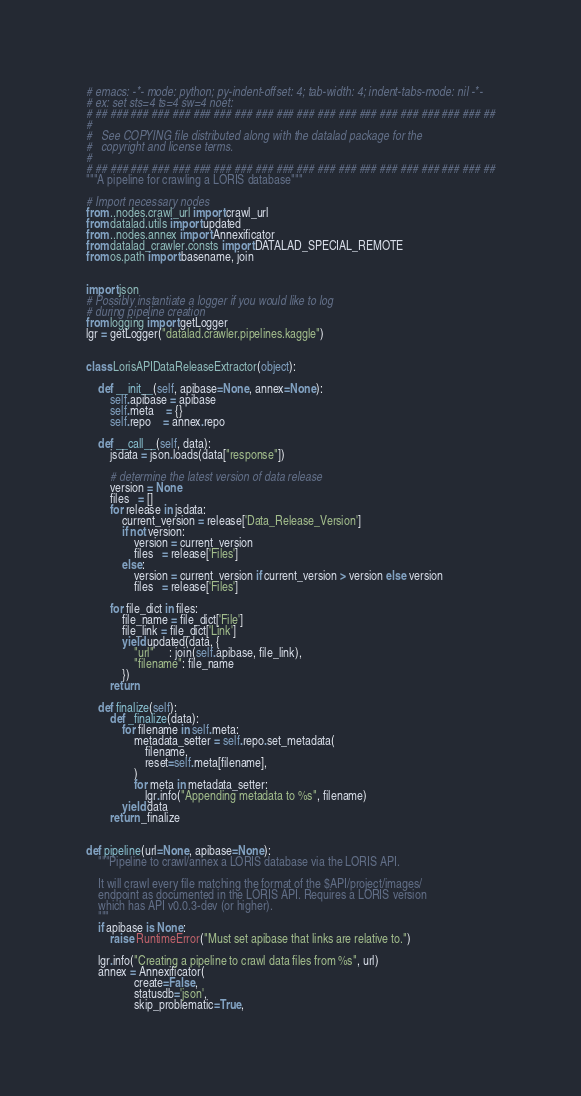<code> <loc_0><loc_0><loc_500><loc_500><_Python_># emacs: -*- mode: python; py-indent-offset: 4; tab-width: 4; indent-tabs-mode: nil -*-
# ex: set sts=4 ts=4 sw=4 noet:
# ## ### ### ### ### ### ### ### ### ### ### ### ### ### ### ### ### ### ### ##
#
#   See COPYING file distributed along with the datalad package for the
#   copyright and license terms.
#
# ## ### ### ### ### ### ### ### ### ### ### ### ### ### ### ### ### ### ### ##
"""A pipeline for crawling a LORIS database"""

# Import necessary nodes
from ..nodes.crawl_url import crawl_url
from datalad.utils import updated
from ..nodes.annex import Annexificator
from datalad_crawler.consts import DATALAD_SPECIAL_REMOTE
from os.path import basename, join


import json
# Possibly instantiate a logger if you would like to log
# during pipeline creation
from logging import getLogger
lgr = getLogger("datalad.crawler.pipelines.kaggle")


class LorisAPIDataReleaseExtractor(object):

    def __init__(self, apibase=None, annex=None):
        self.apibase = apibase
        self.meta    = {}
        self.repo    = annex.repo

    def __call__(self, data):
        jsdata = json.loads(data["response"])

        # determine the latest version of data release
        version = None
        files   = []
        for release in jsdata:
            current_version = release['Data_Release_Version']
            if not version:
                version = current_version
                files   = release['Files']
            else:
                version = current_version if current_version > version else version
                files   = release['Files']

        for file_dict in files:
            file_name = file_dict['File']
            file_link = file_dict['Link']
            yield updated(data, {
                "url"     : join(self.apibase, file_link),
                "filename": file_name
            })
        return

    def finalize(self):
        def _finalize(data):
            for filename in self.meta:
                metadata_setter = self.repo.set_metadata(
                    filename,
                    reset=self.meta[filename],
                )
                for meta in metadata_setter:
                    lgr.info("Appending metadata to %s", filename)
            yield data
        return _finalize


def pipeline(url=None, apibase=None):
    """Pipeline to crawl/annex a LORIS database via the LORIS API.
    
    It will crawl every file matching the format of the $API/project/images/
    endpoint as documented in the LORIS API. Requires a LORIS version
    which has API v0.0.3-dev (or higher).
    """
    if apibase is None:
        raise RuntimeError("Must set apibase that links are relative to.")

    lgr.info("Creating a pipeline to crawl data files from %s", url)
    annex = Annexificator(
                create=False,
                statusdb='json',
                skip_problematic=True,</code> 